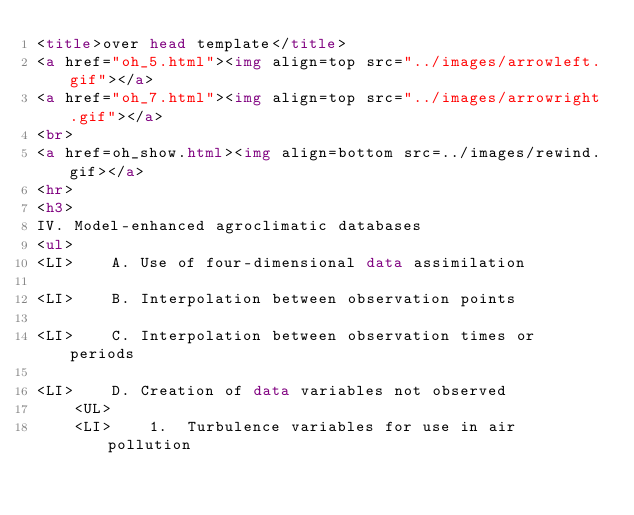Convert code to text. <code><loc_0><loc_0><loc_500><loc_500><_HTML_><title>over head template</title>
<a href="oh_5.html"><img align=top src="../images/arrowleft.gif"></a>
<a href="oh_7.html"><img align=top src="../images/arrowright.gif"></a>
<br>
<a href=oh_show.html><img align=bottom src=../images/rewind.gif></a>
<hr>
<h3>
IV. Model-enhanced agroclimatic databases
<ul>
<LI>	A. Use of four-dimensional data assimilation

<LI>	B. Interpolation between observation points

<LI>	C. Interpolation between observation times or periods

<LI>	D. Creation of data variables not observed
	<UL>
	<LI>	1.  Turbulence variables for use in air pollution</code> 